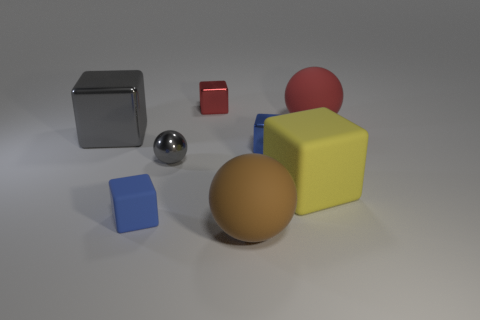Add 2 large red rubber balls. How many objects exist? 10 Subtract all cubes. How many objects are left? 3 Add 8 blue metal blocks. How many blue metal blocks exist? 9 Subtract 1 brown balls. How many objects are left? 7 Subtract all large brown blocks. Subtract all small blue rubber objects. How many objects are left? 7 Add 5 blue matte objects. How many blue matte objects are left? 6 